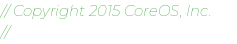Convert code to text. <code><loc_0><loc_0><loc_500><loc_500><_Go_>// Copyright 2015 CoreOS, Inc.
//</code> 